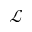<formula> <loc_0><loc_0><loc_500><loc_500>\mathcal { L }</formula> 